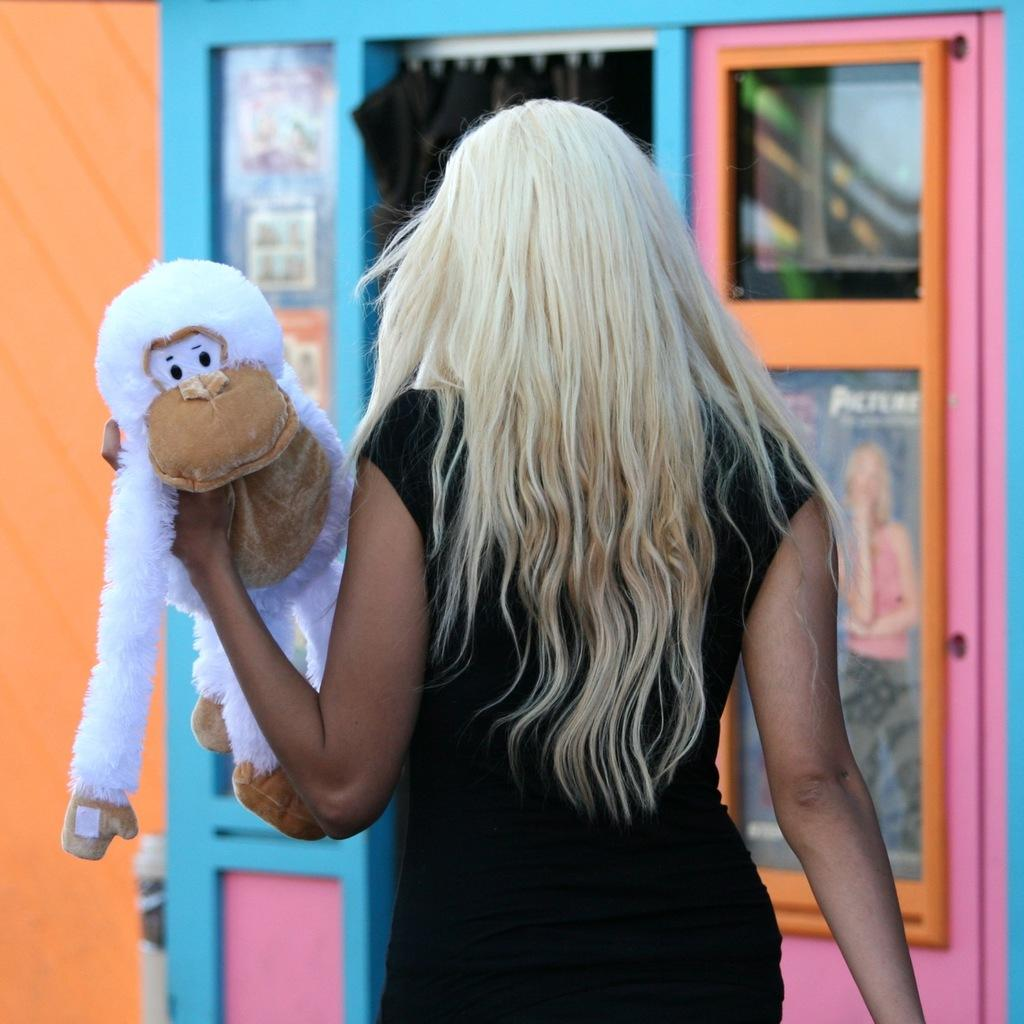Who is present in the image? There is a person in the image. What is the person holding in the image? The person is holding a toy. What can be seen in the background of the image? There is a wall and doors in the background of the image. What type of substance is being used to clean the cemetery in the image? There is no cemetery or substance present in the image. 